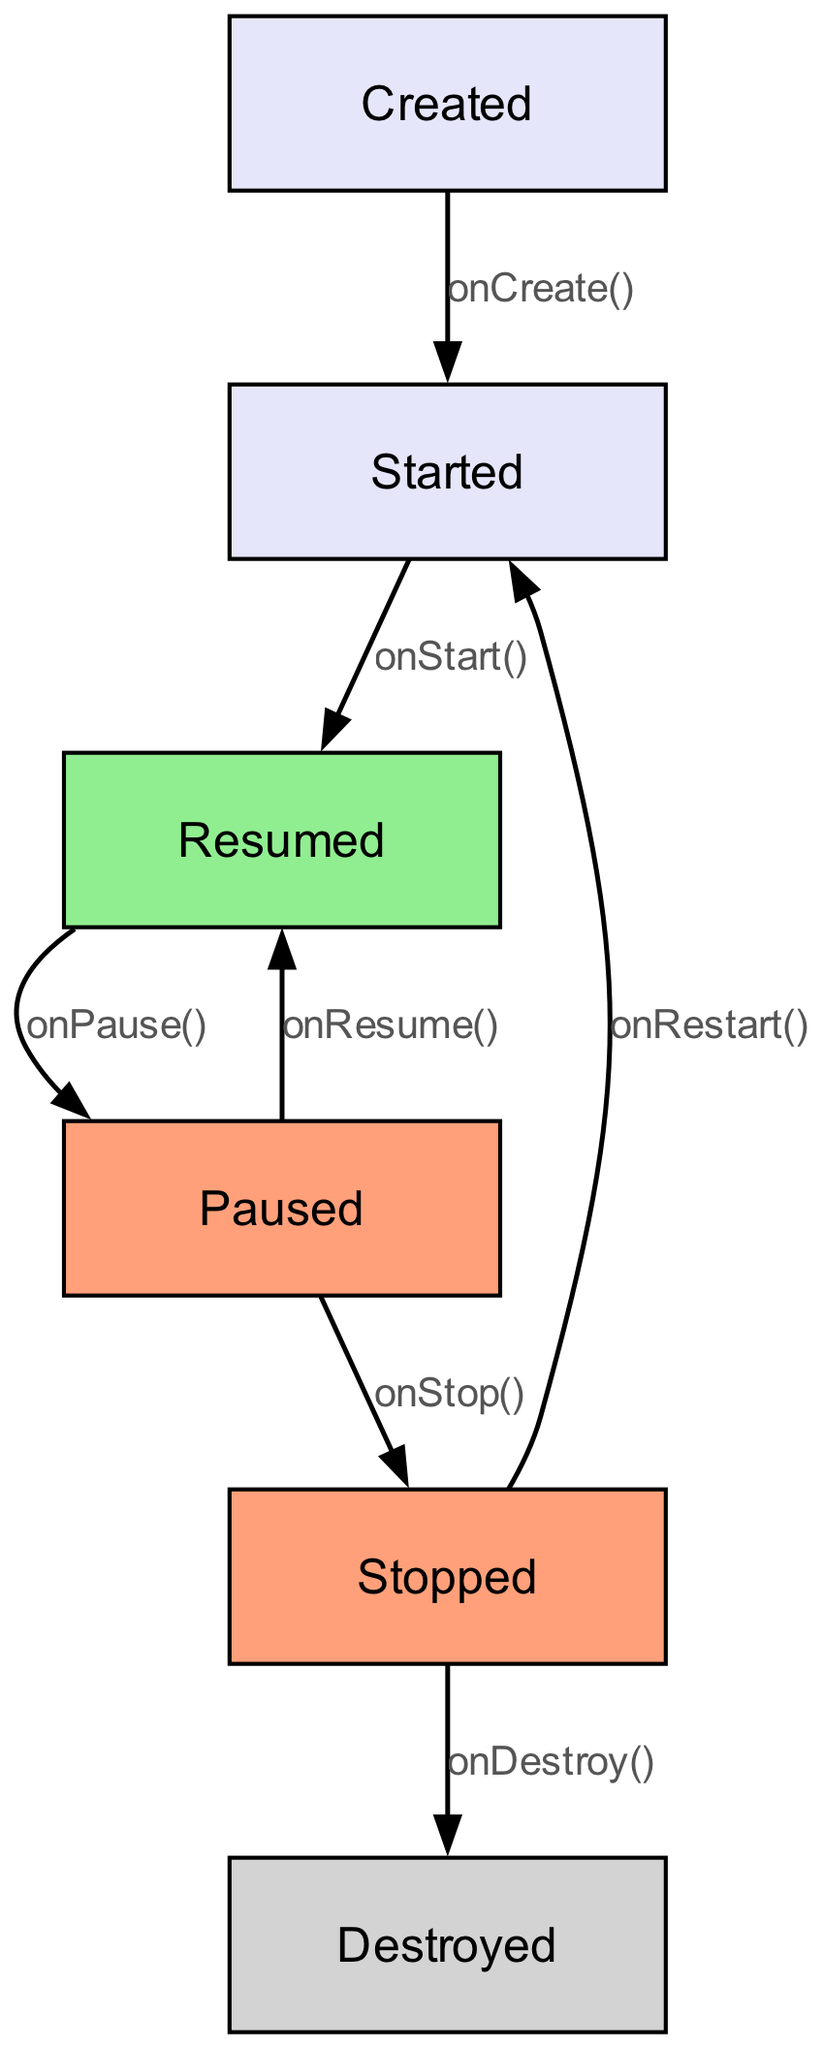What are the five lifecycle states represented in the diagram? The diagram includes the states: Created, Started, Resumed, Paused, Stopped, and Destroyed. These are the key points in the Android activity lifecycle that are visualized as nodes.
Answer: Created, Started, Resumed, Paused, Stopped, Destroyed Which state comes after "Created"? The edge labeled "onCreate()" connects the "Created" state to the "Started" state. This indicates that after the "Created" state, the next transition occurs to the "Started" state due to the onCreate method being called.
Answer: Started How many transitions are shown in the diagram? The diagram visualizes the transitions as edges between the states. There are a total of seven edges representing the lifecycle transitions as shown in the provided data.
Answer: Seven What label is used for the transition from "Paused" to "Stopped"? The transition from "Paused" to "Stopped" is labeled "onStop()". This label indicates the method that triggers this specific transition in the Android lifecycle.
Answer: onStop() Which state is represented in light green color? The state "Resumed" is highlighted in light green in the diagram. This color coding signifies that it is the active or foreground state of the activity within the Android lifecycle.
Answer: Resumed What happens when the "Stopped" state transitions to "Started"? The "Stopped" state transitions back to "Started" when the "onRestart()" method is called. This indicates that the activity was stopped and is now being restarted.
Answer: onRestart() What is the last state in the lifecycle flow shown in the diagram? The last state represented in the lifecycle diagram is "Destroyed". This state signifies the end of the activity's lifecycle after it has been completely shut down.
Answer: Destroyed Which state can go back to "Resumed"? The "Paused" state can transition back to "Resumed" via the "onResume()" method call. This represents the flow where an activity that was paused can become active again.
Answer: Paused 